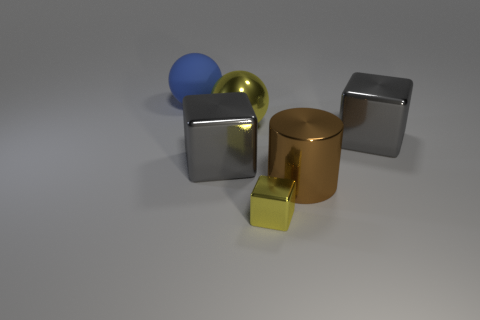Is there anything in the image that indicates size or scale? Nothing in the image explicitly indicates the actual size or scale of the objects; the absence of familiar objects or a known reference point makes it impossible to accurately determine their size. 